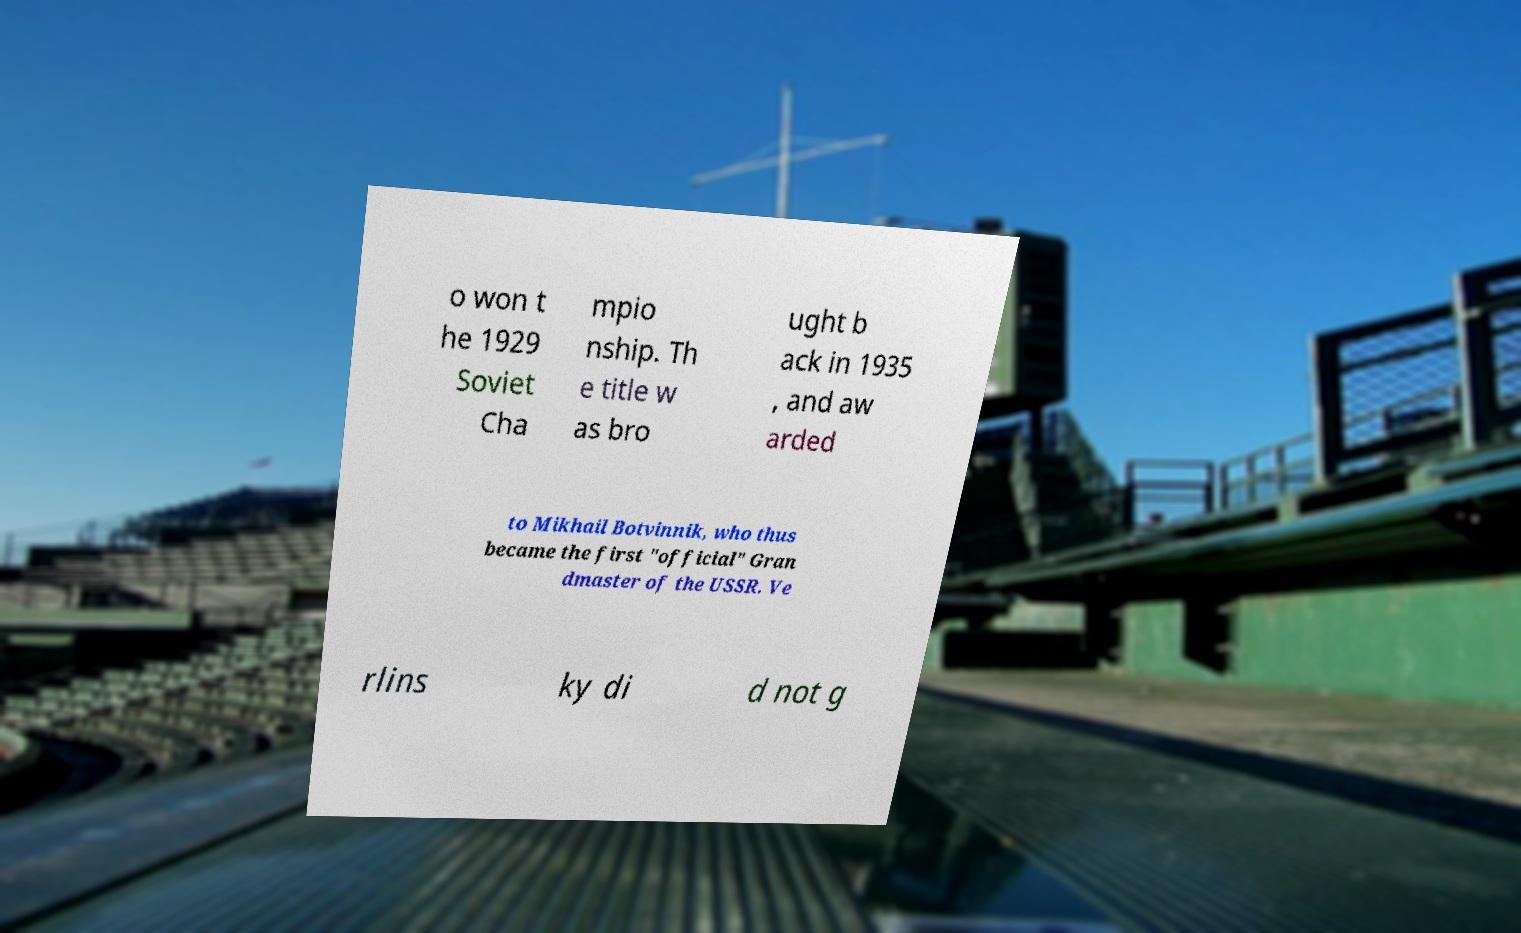Could you assist in decoding the text presented in this image and type it out clearly? o won t he 1929 Soviet Cha mpio nship. Th e title w as bro ught b ack in 1935 , and aw arded to Mikhail Botvinnik, who thus became the first "official" Gran dmaster of the USSR. Ve rlins ky di d not g 